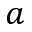<formula> <loc_0><loc_0><loc_500><loc_500>a</formula> 